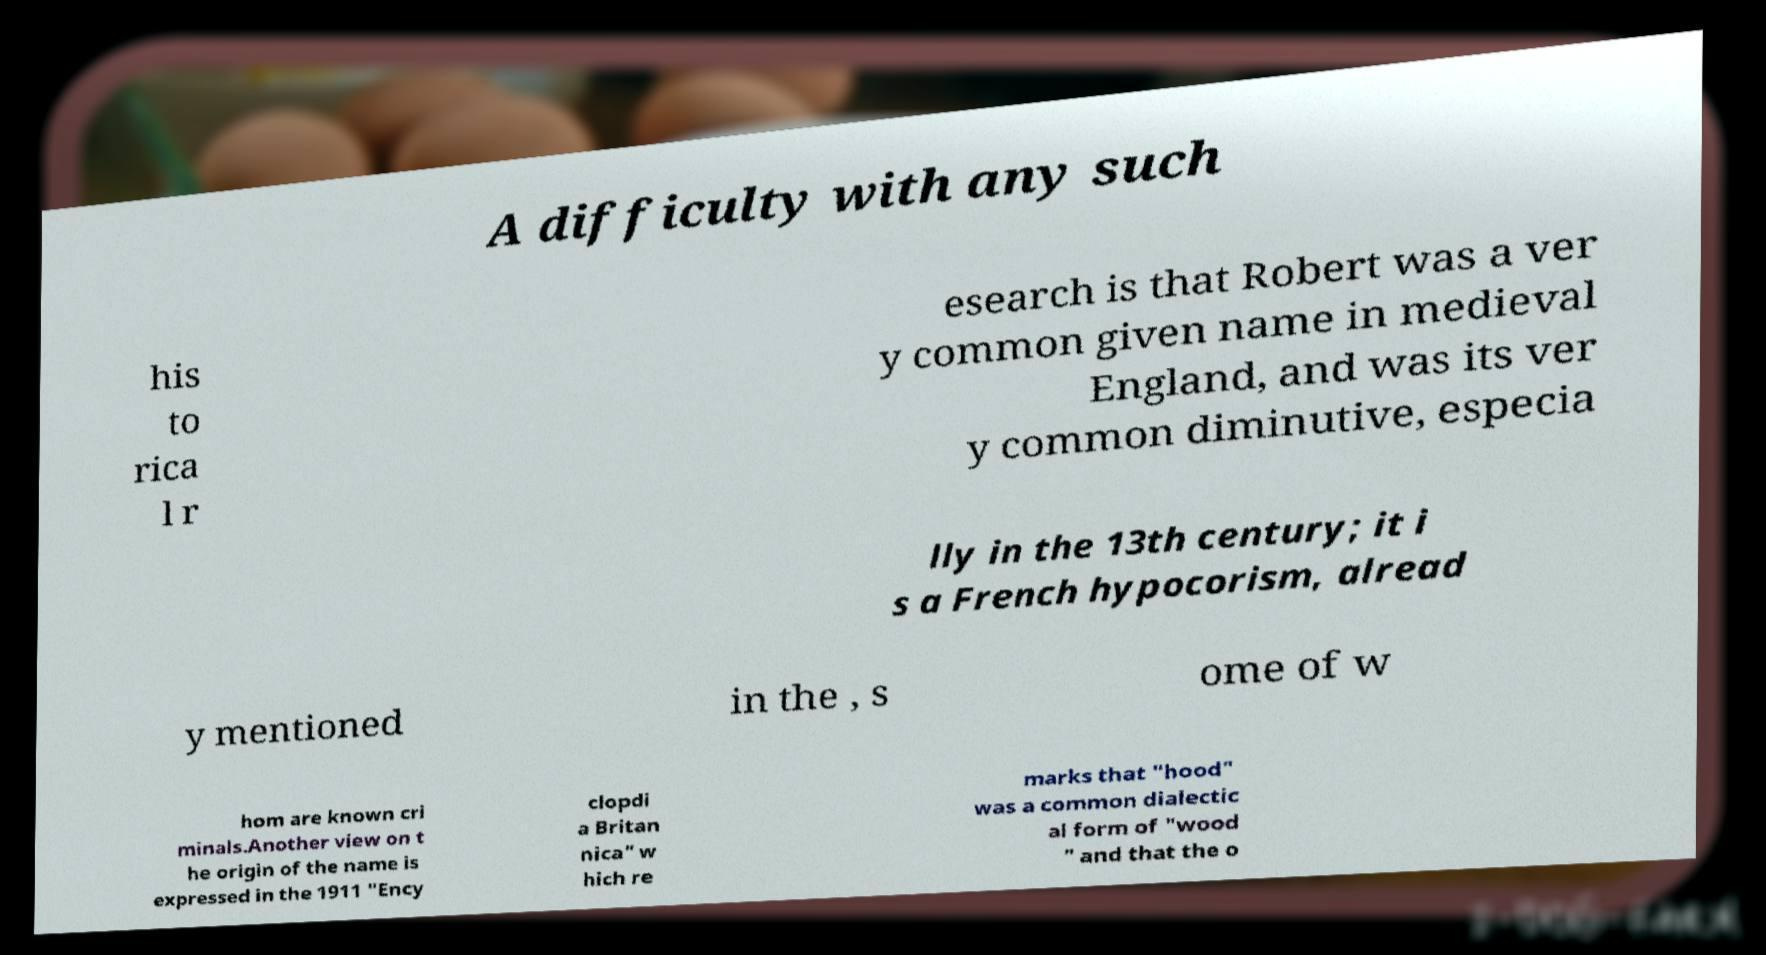For documentation purposes, I need the text within this image transcribed. Could you provide that? A difficulty with any such his to rica l r esearch is that Robert was a ver y common given name in medieval England, and was its ver y common diminutive, especia lly in the 13th century; it i s a French hypocorism, alread y mentioned in the , s ome of w hom are known cri minals.Another view on t he origin of the name is expressed in the 1911 "Ency clopdi a Britan nica" w hich re marks that "hood" was a common dialectic al form of "wood " and that the o 